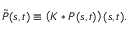Convert formula to latex. <formula><loc_0><loc_0><loc_500><loc_500>\tilde { P } ( s , t ) \equiv \left ( K * P ( s , t ) \right ) ( s , t ) .</formula> 